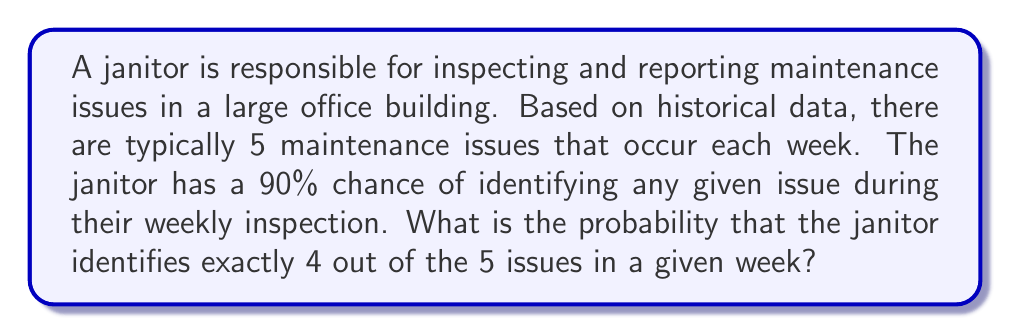Show me your answer to this math problem. To solve this problem, we'll use the binomial probability formula, as we're dealing with a fixed number of independent trials (5 issues) with a constant probability of success (90% chance of identifying each issue).

Step 1: Identify the parameters
- $n = 5$ (total number of issues)
- $k = 4$ (number of successes we're looking for)
- $p = 0.90$ (probability of success for each trial)
- $q = 1 - p = 0.10$ (probability of failure for each trial)

Step 2: Apply the binomial probability formula
$$P(X = k) = \binom{n}{k} p^k q^{n-k}$$

Step 3: Calculate the binomial coefficient
$$\binom{5}{4} = \frac{5!}{4!(5-4)!} = \frac{5!}{4!1!} = 5$$

Step 4: Substitute values into the formula
$$P(X = 4) = 5 \cdot (0.90)^4 \cdot (0.10)^{5-4}$$
$$= 5 \cdot (0.90)^4 \cdot (0.10)^1$$

Step 5: Calculate the result
$$= 5 \cdot 0.6561 \cdot 0.10$$
$$= 0.32805$$

Therefore, the probability that the janitor identifies exactly 4 out of the 5 issues in a given week is approximately 0.32805 or 32.805%.
Answer: 0.32805 